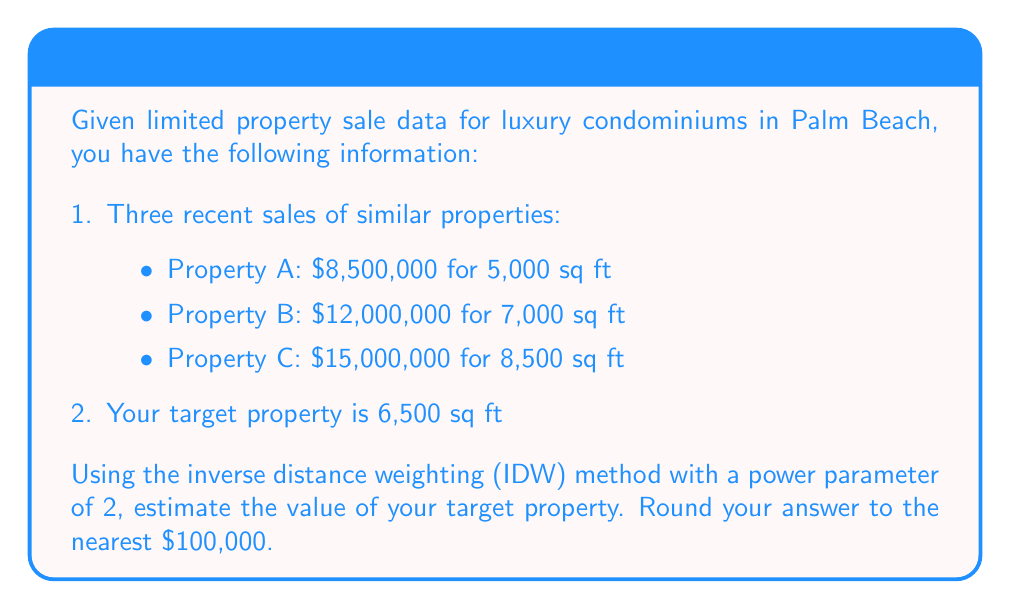Can you solve this math problem? To solve this problem using the inverse distance weighting (IDW) method, we'll follow these steps:

1. Calculate the price per square foot for each property:
   Property A: $8,500,000 / 5,000 = $1,700/sq ft
   Property B: $12,000,000 / 7,000 = $1,714.29/sq ft
   Property C: $15,000,000 / 8,500 = $1,764.71/sq ft

2. Calculate the distance (difference in square footage) between each property and the target property:
   Property A: |6,500 - 5,000| = 1,500 sq ft
   Property B: |6,500 - 7,000| = 500 sq ft
   Property C: |6,500 - 8,500| = 2,000 sq ft

3. Apply the IDW formula:
   $$v = \frac{\sum_{i=1}^n \frac{v_i}{d_i^p}}{\sum_{i=1}^n \frac{1}{d_i^p}}$$
   
   Where:
   $v$ is the estimated value per square foot
   $v_i$ is the known value per square foot of property i
   $d_i$ is the distance between the target property and property i
   $p$ is the power parameter (2 in this case)

4. Plug in the values:
   $$v = \frac{\frac{1700}{1500^2} + \frac{1714.29}{500^2} + \frac{1764.71}{2000^2}}{\frac{1}{1500^2} + \frac{1}{500^2} + \frac{1}{2000^2}}$$

5. Simplify and calculate:
   $$v \approx 1720.83$$ (per square foot)

6. Multiply by the target property size:
   Estimated value = 1720.83 * 6,500 = $11,185,395

7. Round to the nearest $100,000:
   $11,200,000
Answer: $11,200,000 